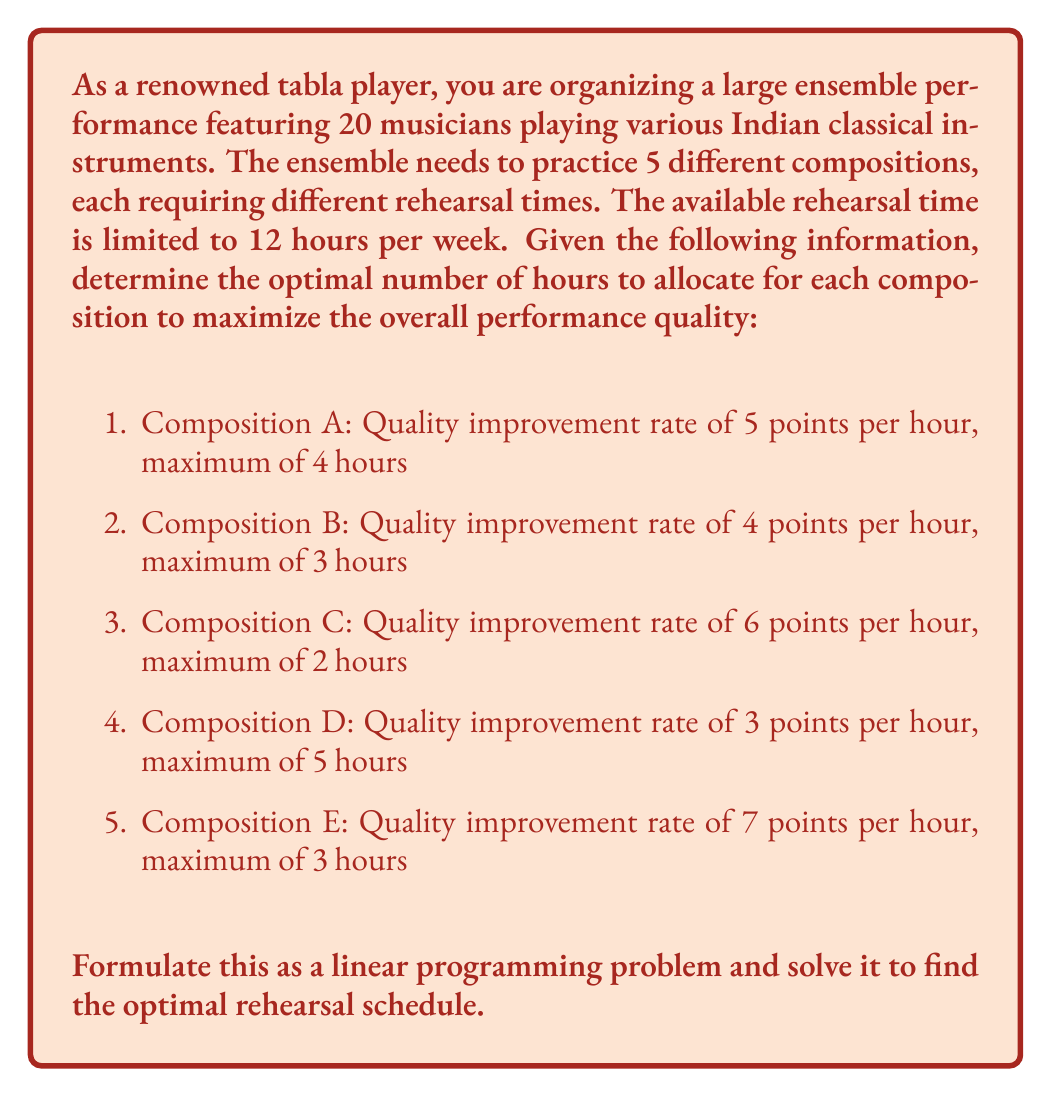Can you answer this question? To solve this problem, we'll use linear programming. Let's follow these steps:

1. Define variables:
   Let $x_A, x_B, x_C, x_D, x_E$ represent the number of hours allocated to each composition.

2. Formulate the objective function:
   Maximize $Z = 5x_A + 4x_B + 6x_C + 3x_D + 7x_E$

3. Define constraints:
   a) Time constraints for each composition:
      $0 \leq x_A \leq 4$
      $0 \leq x_B \leq 3$
      $0 \leq x_C \leq 2$
      $0 \leq x_D \leq 5$
      $0 \leq x_E \leq 3$
   
   b) Total time constraint:
      $x_A + x_B + x_C + x_D + x_E \leq 12$

4. Solve using the simplex method or a linear programming solver:

   The optimal solution is:
   $x_A = 4, x_B = 3, x_C = 2, x_D = 0, x_E = 3$

5. Calculate the maximum quality improvement:
   $Z = 5(4) + 4(3) + 6(2) + 3(0) + 7(3) = 20 + 12 + 12 + 0 + 21 = 65$

Therefore, the optimal rehearsal schedule allocates 4 hours to Composition A, 3 hours to Composition B, 2 hours to Composition C, 0 hours to Composition D, and 3 hours to Composition E, resulting in a total quality improvement of 65 points.
Answer: $x_A = 4, x_B = 3, x_C = 2, x_D = 0, x_E = 3$ 